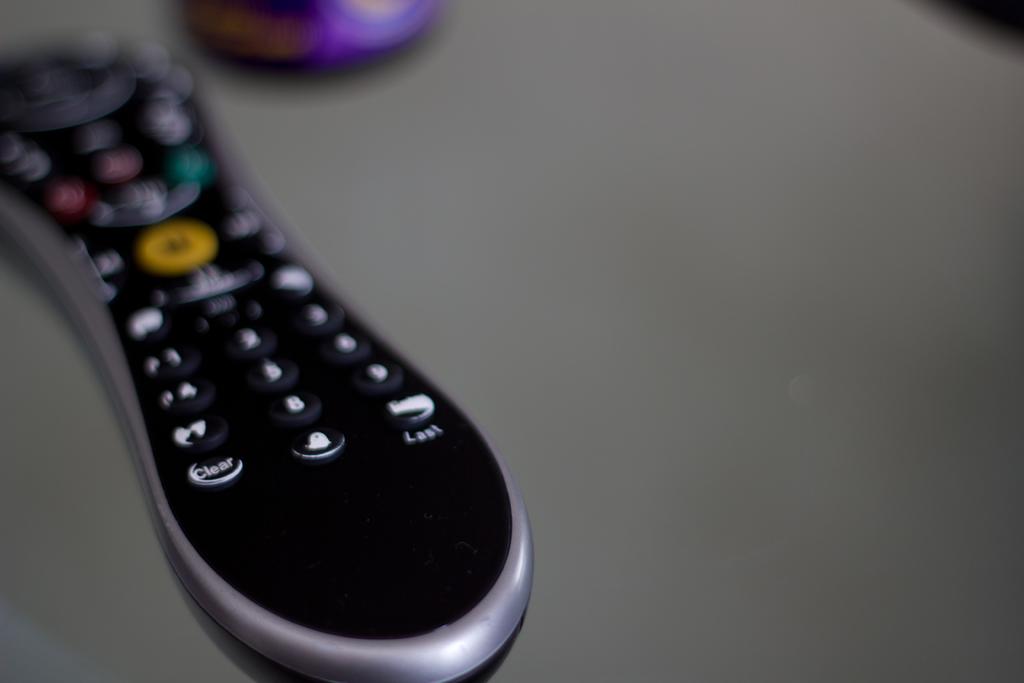What is the button on the lower right corner of this remote?
Provide a succinct answer. Last. 